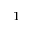<formula> <loc_0><loc_0><loc_500><loc_500>_ { 1 }</formula> 